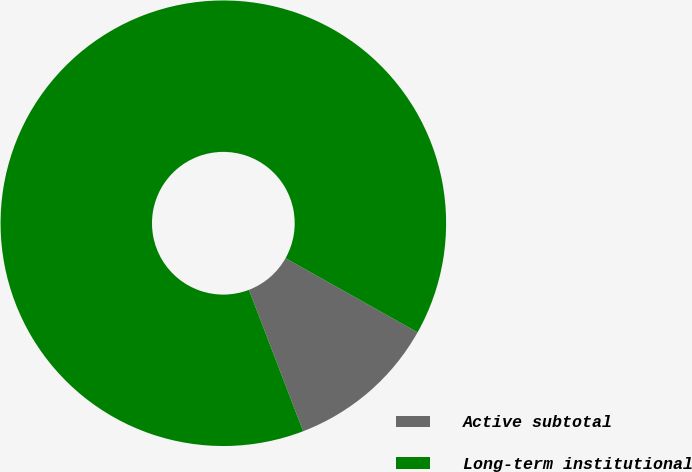<chart> <loc_0><loc_0><loc_500><loc_500><pie_chart><fcel>Active subtotal<fcel>Long-term institutional<nl><fcel>11.02%<fcel>88.98%<nl></chart> 